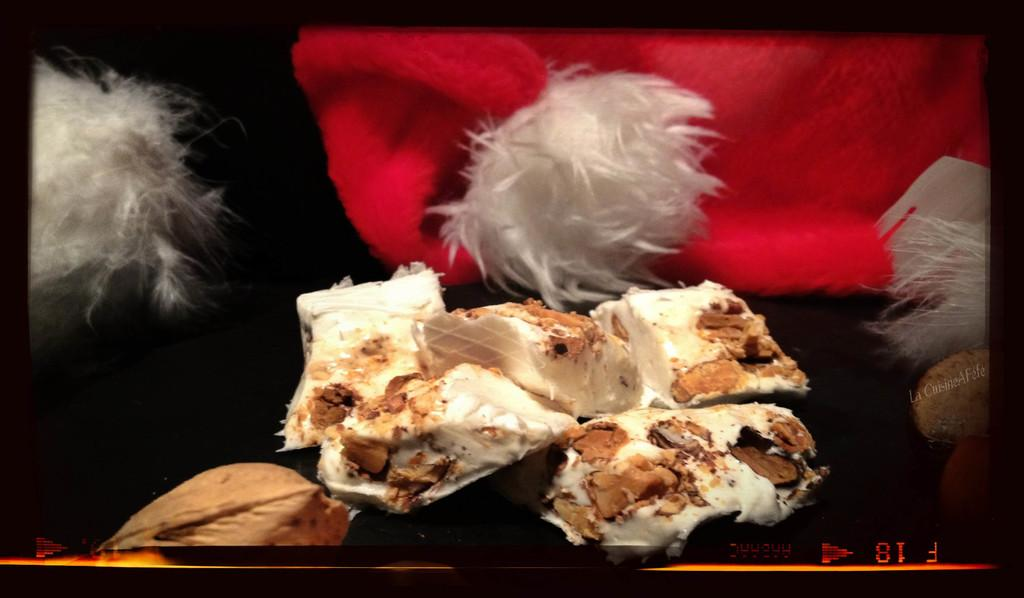What is the main object in the image? There is a display screen in the image. What is being displayed on the screen? The display screen shows deserts. What other items can be seen in the image? There are red color caps visible in the image. Is there any text present in the image? Yes, there is text present in the image. What type of yak can be seen walking through the desert in the image? There is no yak present in the image; it only shows deserts on the display screen. How is the oil being used in the image? There is no oil present in the image. 